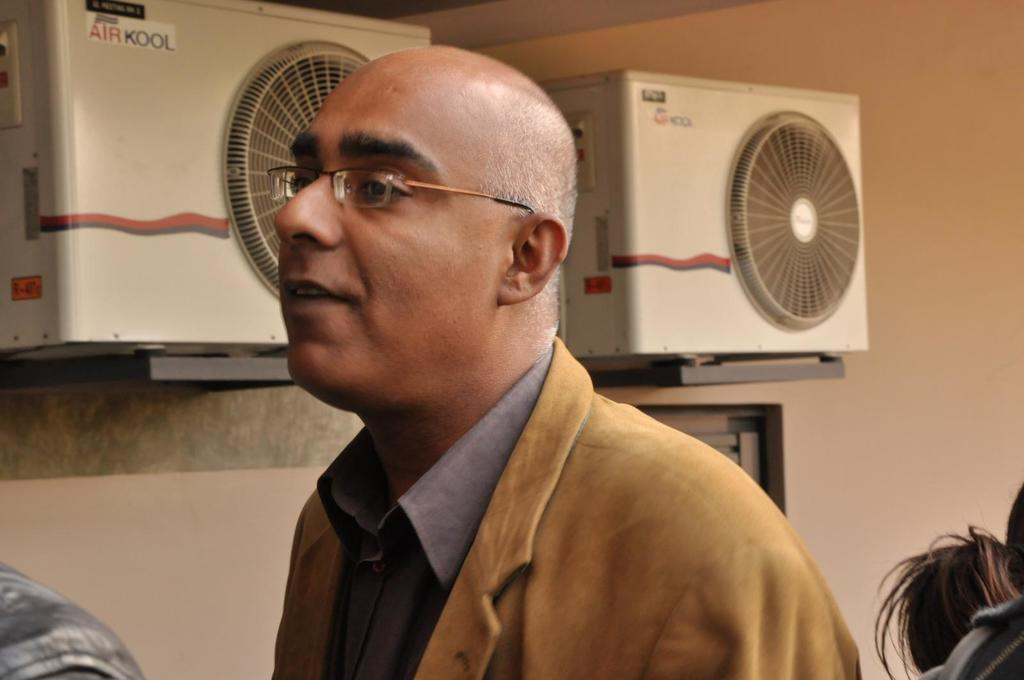What is the appearance of the man in the image? The man in the image is bald-headed. What is the man wearing in the image? The man is wearing a yellow jacket and spectacles. Are there any other people in the image? Yes, there appear to be two persons on either side of the bald-headed man. What can be seen on the wall in the background of the image? There are exhaust fan machines on the wall in the background of the image. What type of stem is the bald-headed man holding in the image? There is no stem present in the image; the bald-headed man is not holding anything. Is the bald-headed man sitting on a throne in the image? No, there is no throne present in the image. 